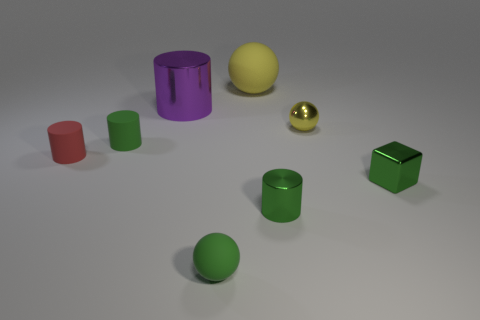Add 1 shiny balls. How many objects exist? 9 Subtract all blocks. How many objects are left? 7 Add 6 big metal objects. How many big metal objects are left? 7 Add 3 purple metallic things. How many purple metallic things exist? 4 Subtract 0 blue blocks. How many objects are left? 8 Subtract all big objects. Subtract all green matte cylinders. How many objects are left? 5 